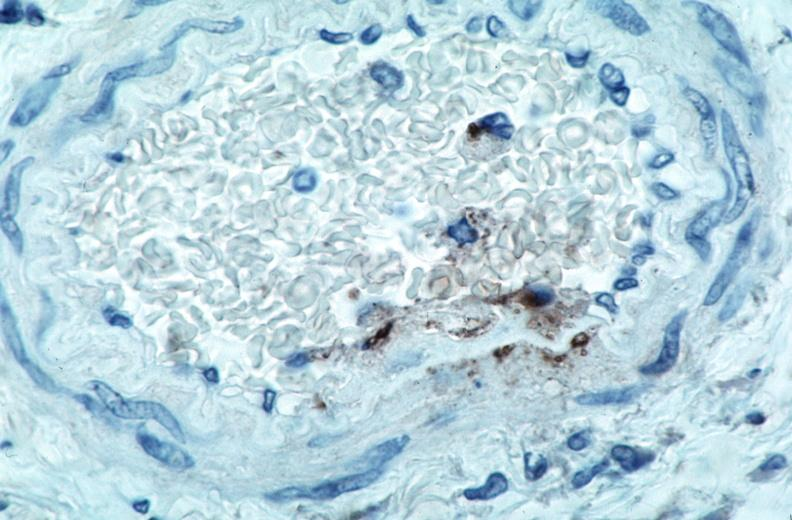s peritoneum present?
Answer the question using a single word or phrase. No 